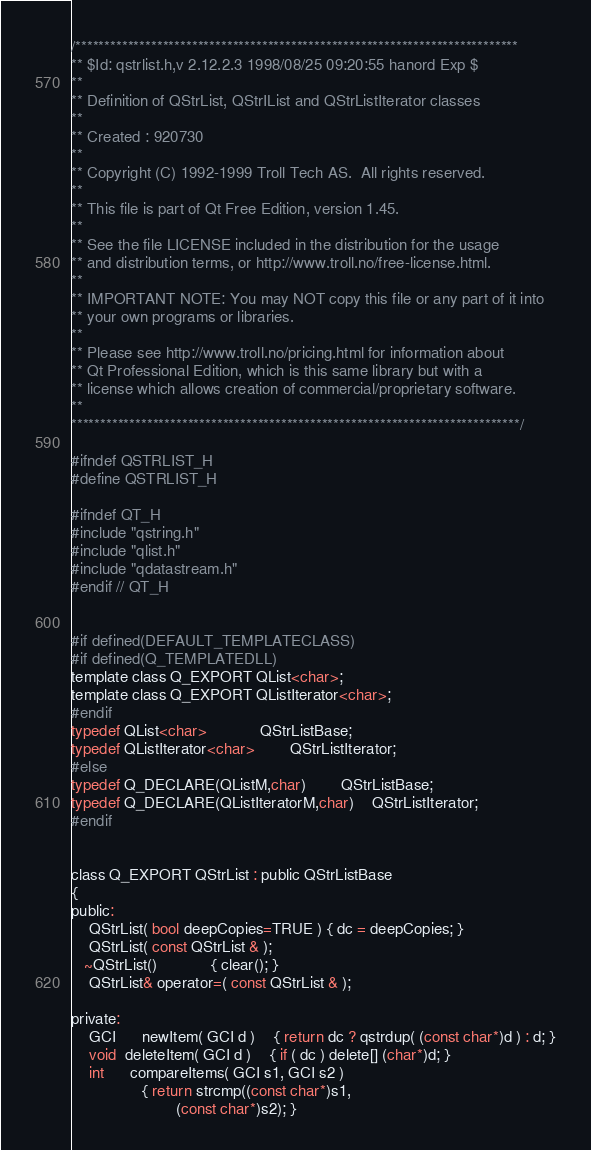Convert code to text. <code><loc_0><loc_0><loc_500><loc_500><_C_>/****************************************************************************
** $Id: qstrlist.h,v 2.12.2.3 1998/08/25 09:20:55 hanord Exp $
**
** Definition of QStrList, QStrIList and QStrListIterator classes
**
** Created : 920730
**
** Copyright (C) 1992-1999 Troll Tech AS.  All rights reserved.
**
** This file is part of Qt Free Edition, version 1.45.
**
** See the file LICENSE included in the distribution for the usage
** and distribution terms, or http://www.troll.no/free-license.html.
**
** IMPORTANT NOTE: You may NOT copy this file or any part of it into
** your own programs or libraries.
**
** Please see http://www.troll.no/pricing.html for information about 
** Qt Professional Edition, which is this same library but with a
** license which allows creation of commercial/proprietary software.
**
*****************************************************************************/

#ifndef QSTRLIST_H
#define QSTRLIST_H

#ifndef QT_H
#include "qstring.h"
#include "qlist.h"
#include "qdatastream.h"
#endif // QT_H


#if defined(DEFAULT_TEMPLATECLASS)
#if defined(Q_TEMPLATEDLL)
template class Q_EXPORT QList<char>;
template class Q_EXPORT QListIterator<char>;
#endif
typedef QList<char>			QStrListBase;
typedef QListIterator<char>		QStrListIterator;
#else
typedef Q_DECLARE(QListM,char)		QStrListBase;
typedef Q_DECLARE(QListIteratorM,char)	QStrListIterator;
#endif


class Q_EXPORT QStrList : public QStrListBase
{
public:
    QStrList( bool deepCopies=TRUE ) { dc = deepCopies; }
    QStrList( const QStrList & );
   ~QStrList()			{ clear(); }
    QStrList& operator=( const QStrList & );

private:
    GCI	  newItem( GCI d )	{ return dc ? qstrdup( (const char*)d ) : d; }
    void  deleteItem( GCI d )	{ if ( dc ) delete[] (char*)d; }
    int	  compareItems( GCI s1, GCI s2 )
				{ return strcmp((const char*)s1,
						(const char*)s2); }</code> 